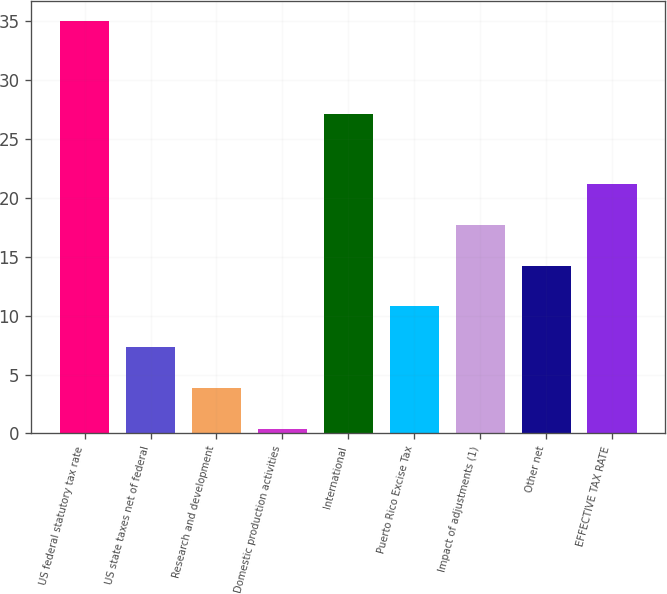Convert chart to OTSL. <chart><loc_0><loc_0><loc_500><loc_500><bar_chart><fcel>US federal statutory tax rate<fcel>US state taxes net of federal<fcel>Research and development<fcel>Domestic production activities<fcel>International<fcel>Puerto Rico Excise Tax<fcel>Impact of adjustments (1)<fcel>Other net<fcel>EFFECTIVE TAX RATE<nl><fcel>35<fcel>7.32<fcel>3.86<fcel>0.4<fcel>27.1<fcel>10.78<fcel>17.7<fcel>14.24<fcel>21.16<nl></chart> 